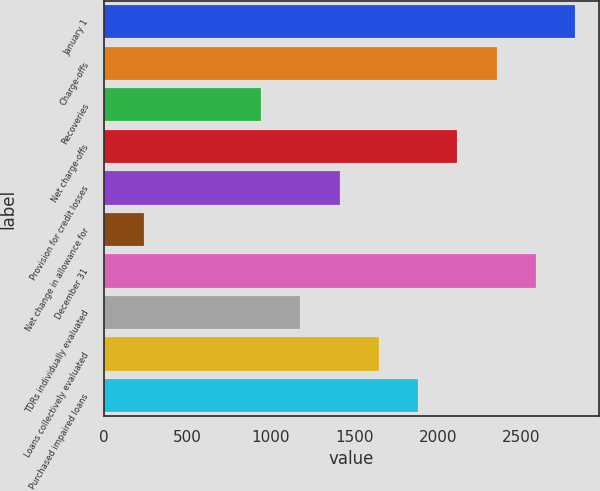Convert chart. <chart><loc_0><loc_0><loc_500><loc_500><bar_chart><fcel>January 1<fcel>Charge-offs<fcel>Recoveries<fcel>Net charge-offs<fcel>Provision for credit losses<fcel>Net change in allowance for<fcel>December 31<fcel>TDRs individually evaluated<fcel>Loans collectively evaluated<fcel>Purchased impaired loans<nl><fcel>2821.86<fcel>2352.04<fcel>942.58<fcel>2117.13<fcel>1412.4<fcel>237.85<fcel>2586.95<fcel>1177.49<fcel>1647.31<fcel>1882.22<nl></chart> 